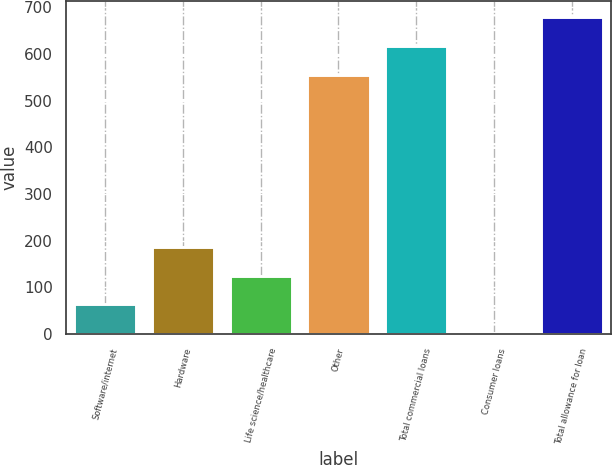<chart> <loc_0><loc_0><loc_500><loc_500><bar_chart><fcel>Software/internet<fcel>Hardware<fcel>Life science/healthcare<fcel>Other<fcel>Total commercial loans<fcel>Consumer loans<fcel>Total allowance for loan<nl><fcel>63.4<fcel>186.2<fcel>124.8<fcel>556<fcel>617.4<fcel>2<fcel>678.8<nl></chart> 